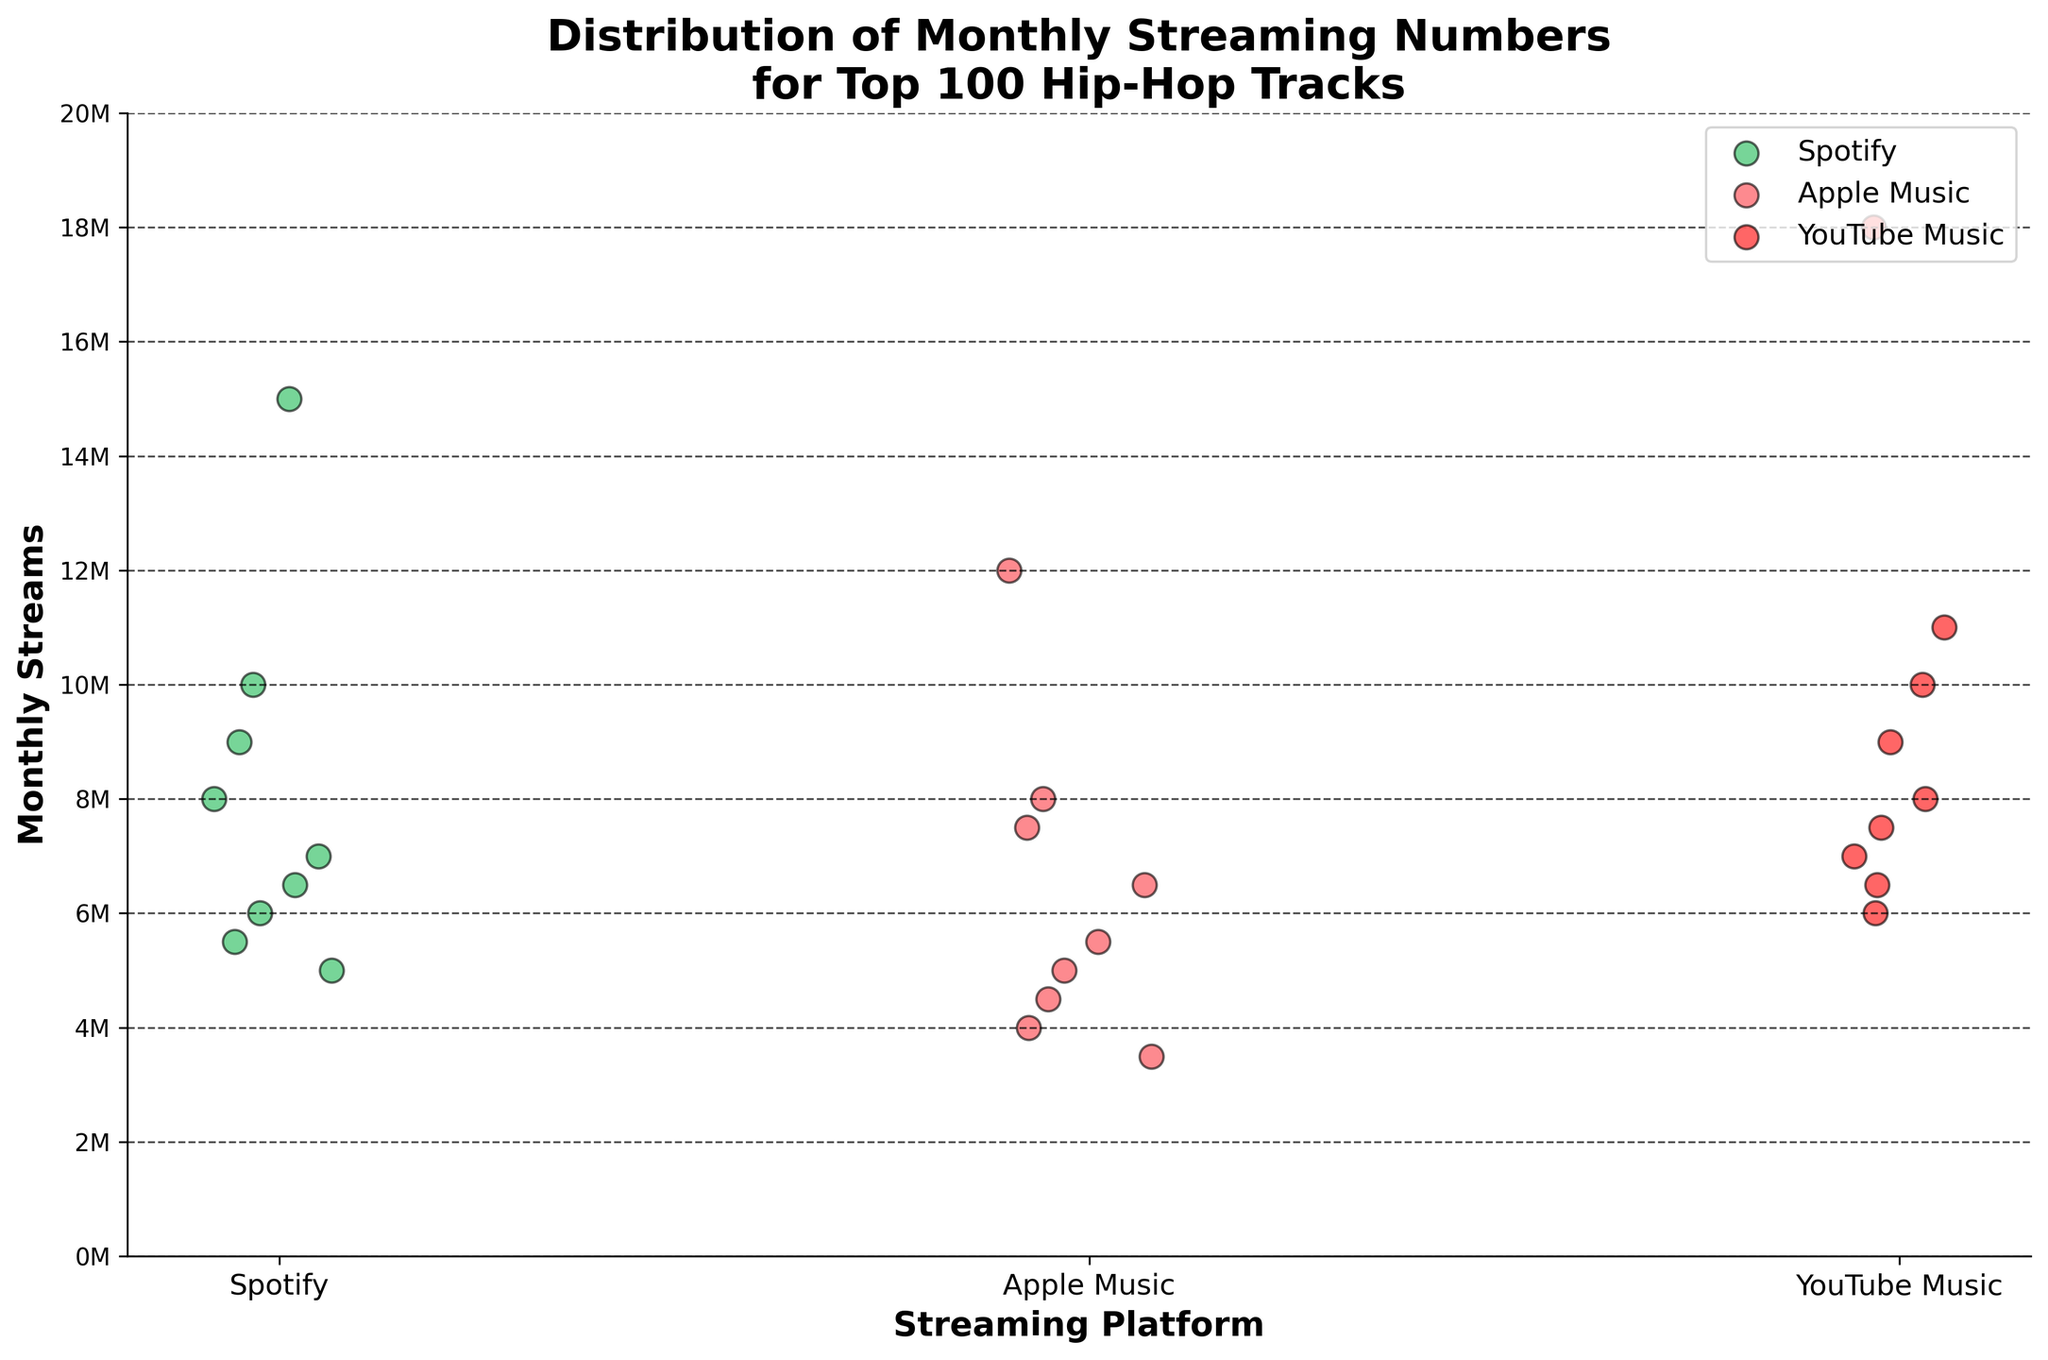What is the title of the figure? The title is located at the top of the chart. It is usually the largest text and describes the main message of the graph.
Answer: Distribution of Monthly Streaming Numbers for Top 100 Hip-Hop Tracks Which platform shows the highest monthly streams for a single track? Look for the highest point on the y-axis and note the corresponding platform on the x-axis. The single track with the highest monthly streams is on YouTube Music.
Answer: YouTube Music What is the approximate mean monthly stream count for tracks on Spotify? Sum up the monthly stream values for all tracks on Spotify and divide by the number of tracks. The stream counts for Spotify are (15M, 10M, 9M, 8M, 7M, 6.5M, 6M, 5.5M, 5M). The sum is 67M streams, and there are 9 tracks, so 67M / 9 ≈ 7.44M.
Answer: 7.44M Which platform has the most consistently high stream numbers? Observe the spread of data points on the y-axis for each platform. The platform with data points consistently higher on the y-axis is YouTube Music.
Answer: YouTube Music How do the average monthly streams on Apple Music compare to Spotify? First, find the average monthly streams for Apple Music and then for Spotify. Apple Music streams are (12M, 8M, 7.5M, 6.5M, 5.5M, 5M, 4.5M, 4M, 3.5M), which sum to 56.5M. There are 9 tracks, so the average is 56.5M / 9 ≈ 6.28M. Spotify average is already calculated as 7.44M. Compare them: 6.28M (Apple Music) is less than 7.44M (Spotify).
Answer: Less For the track "Old Town Road," which platform has the maximum monthly streams? Locate the data points for "Old Town Road" across the platforms. The y-value (streams) indicates the maximum on YouTube Music which is 18M.
Answer: YouTube Music On which platform does the track 'Lucid Dreams' receive the least streams? Check the y-axis values for 'Lucid Dreams' across all platforms. The lowest value is on Apple Music with 5M streams.
Answer: Apple Music What is the range of monthly streams on YouTube Music? Identify the highest and lowest points for YouTube Music on the y-axis. The highest stream count is 18M, and the lowest is 6M, so the range is 18M - 6M = 12M.
Answer: 12M Are there more data points above 10M streams on Spotify or Apple Music? Count the number of points above the 10M stream mark for each platform. Spotify has 2 points (15M, 10M), while Apple Music has 1 point (12M).
Answer: Spotify How does the median monthly stream value on YouTube Music compare to Apple Music? Identify the median stream value for each platform. For YouTube Music (18M, 11M, 10M, 9M, 8M, 7.5M, 7M, 6.5M, 6M), the median is the fifth value, 9M. For Apple Music (12M, 8M, 7.5M, 6.5M, 5.5M, 5M, 4.5M, 4M, 3.5M), the median is also the fifth value, 5.5M. Compare the medians: 9M (YouTube Music) is greater than 5.5M (Apple Music).
Answer: Greater 